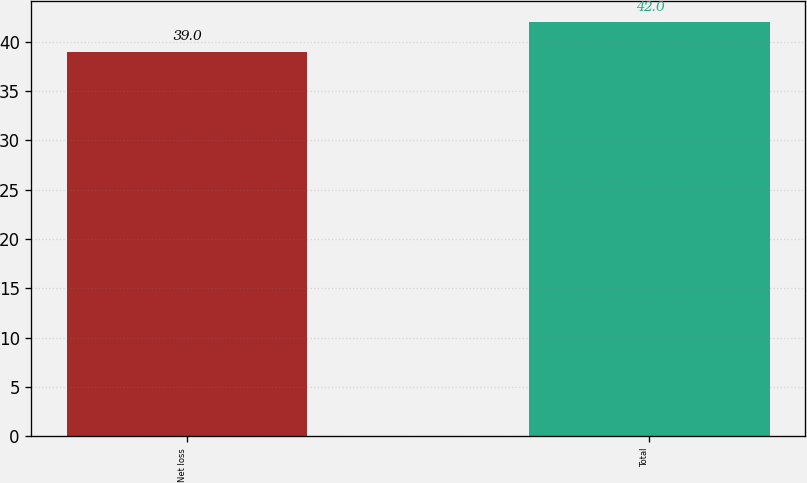<chart> <loc_0><loc_0><loc_500><loc_500><bar_chart><fcel>Net loss<fcel>Total<nl><fcel>39<fcel>42<nl></chart> 